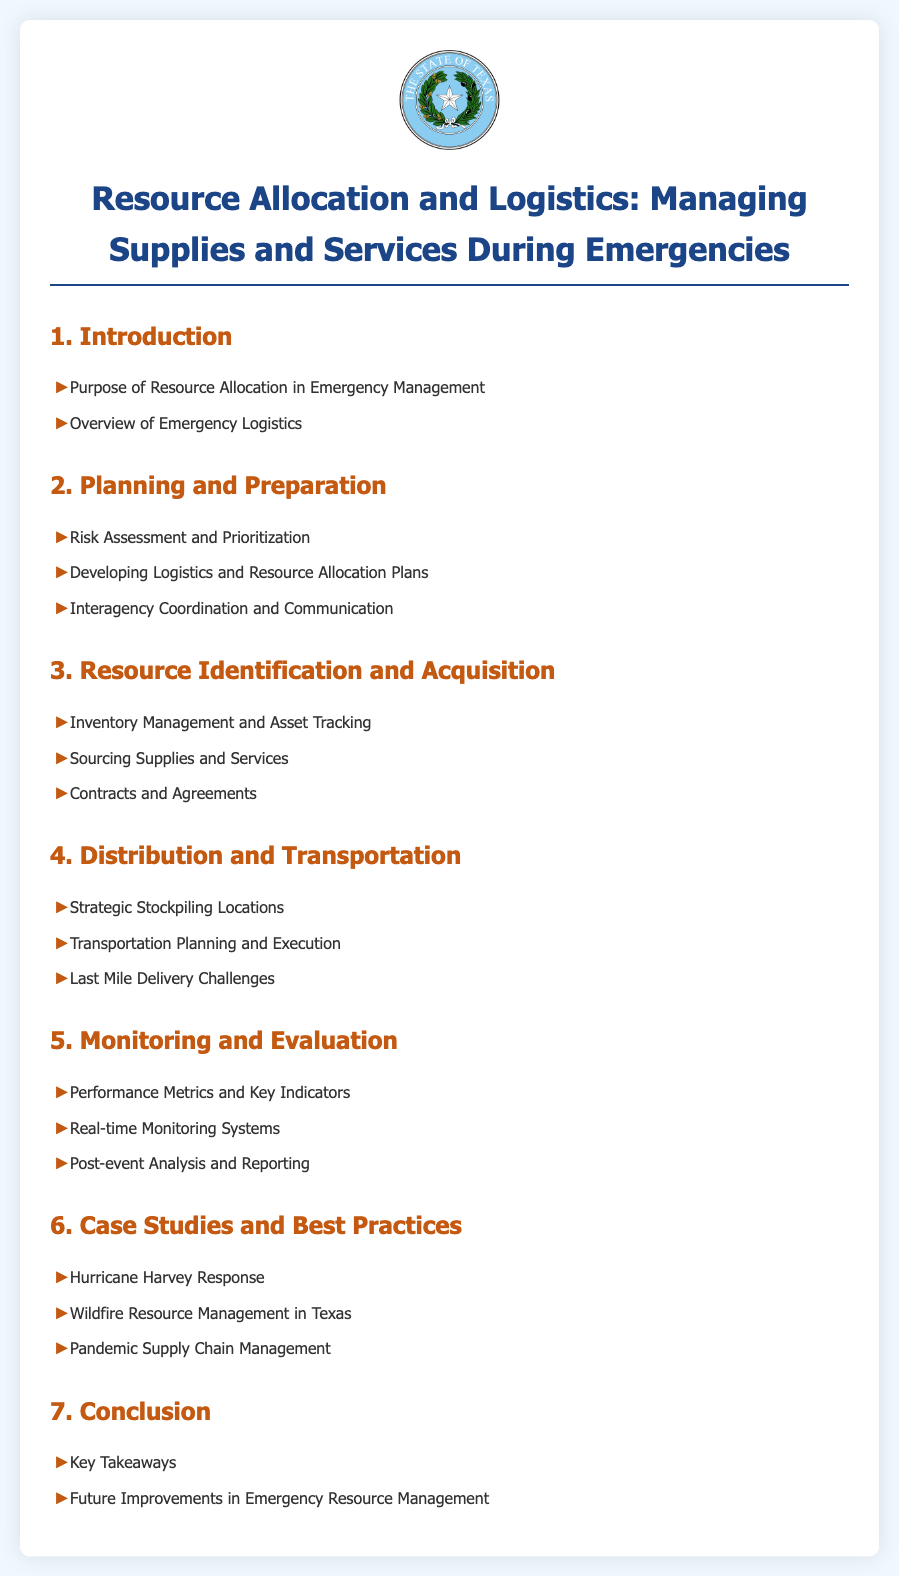What is the title of the document? The title is located at the top of the document, introducing the main topic.
Answer: Resource Allocation and Logistics: Managing Supplies and Services During Emergencies How many main sections are there in the document? The number of main sections is indicated by the headings listed before each section.
Answer: 7 What is one of the key focuses in the 'Distribution and Transportation' section? The document outlines specific focuses under each main section, highlighting areas of concern.
Answer: Last Mile Delivery Challenges Which case study is mentioned in relation to Hurricanes? The case studies provide examples of resource management in specific situations, one related to hurricanes is mentioned.
Answer: Hurricane Harvey Response What is the purpose of resource allocation in emergency management? The purpose is outlined in the introduction section as foundational information for understanding the document.
Answer: Purpose of Resource Allocation in Emergency Management What is a performance metric mentioned in the 'Monitoring and Evaluation' section? This section includes various metrics and indicators for assessing emergency management effectiveness.
Answer: Key Indicators What does the document offer in the 'Conclusion' section? The conclusion summarizes key points discussed and proposes future directions, which is common in reports.
Answer: Key Takeaways 